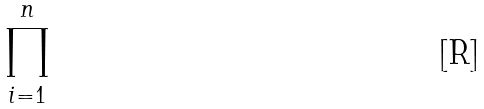Convert formula to latex. <formula><loc_0><loc_0><loc_500><loc_500>\prod _ { i = 1 } ^ { n }</formula> 